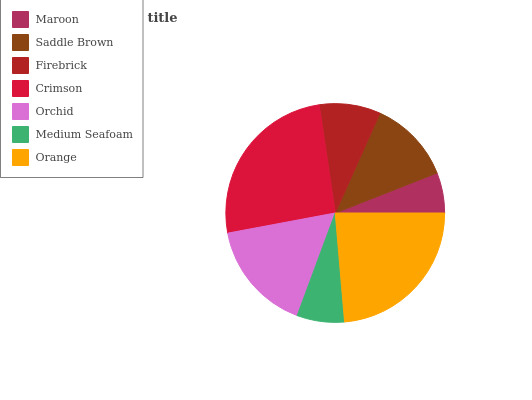Is Maroon the minimum?
Answer yes or no. Yes. Is Crimson the maximum?
Answer yes or no. Yes. Is Saddle Brown the minimum?
Answer yes or no. No. Is Saddle Brown the maximum?
Answer yes or no. No. Is Saddle Brown greater than Maroon?
Answer yes or no. Yes. Is Maroon less than Saddle Brown?
Answer yes or no. Yes. Is Maroon greater than Saddle Brown?
Answer yes or no. No. Is Saddle Brown less than Maroon?
Answer yes or no. No. Is Saddle Brown the high median?
Answer yes or no. Yes. Is Saddle Brown the low median?
Answer yes or no. Yes. Is Crimson the high median?
Answer yes or no. No. Is Crimson the low median?
Answer yes or no. No. 